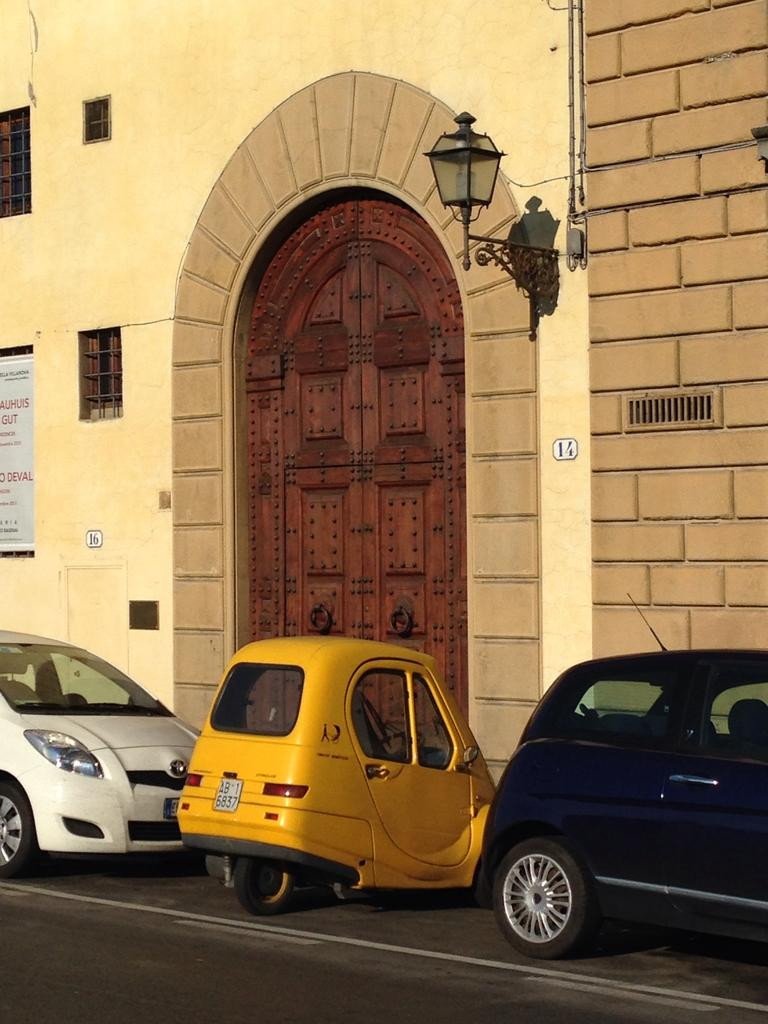What can be seen on the side of the road in the image? There are vehicles parked on the side of the road in the image. What type of structure is present in the image? There is a building in the image. What feature of the building is mentioned in the facts? The building has a big door. What advertisement can be seen on the building in the image? There is no advertisement mentioned in the facts, and therefore no such advertisement can be observed. What is the name of the building in the image? The name of the building is not mentioned in the facts, so it cannot be determined from the image. 